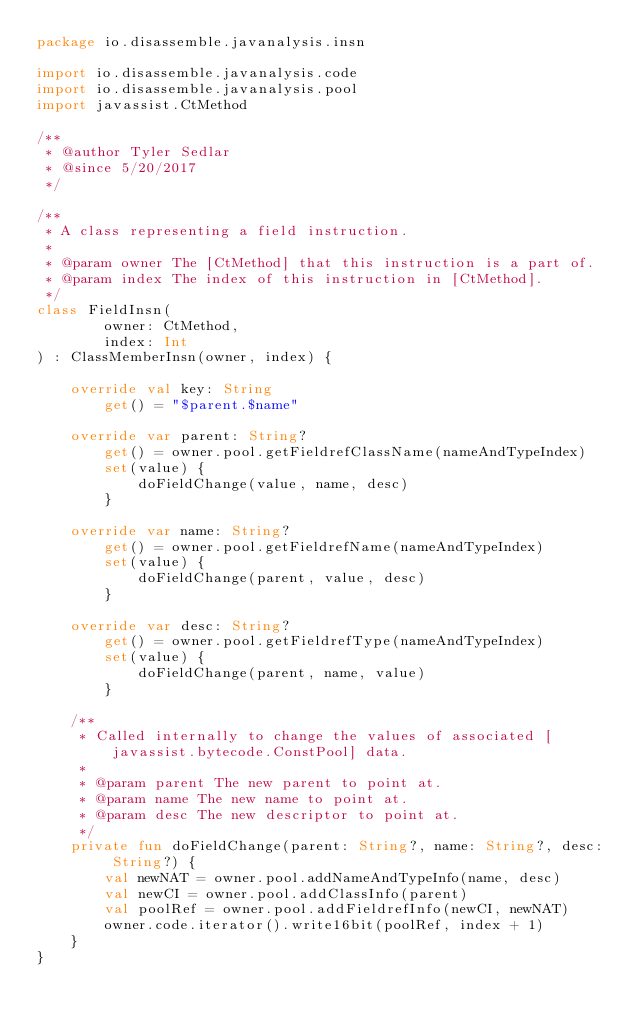Convert code to text. <code><loc_0><loc_0><loc_500><loc_500><_Kotlin_>package io.disassemble.javanalysis.insn

import io.disassemble.javanalysis.code
import io.disassemble.javanalysis.pool
import javassist.CtMethod

/**
 * @author Tyler Sedlar
 * @since 5/20/2017
 */

/**
 * A class representing a field instruction.
 *
 * @param owner The [CtMethod] that this instruction is a part of.
 * @param index The index of this instruction in [CtMethod].
 */
class FieldInsn(
        owner: CtMethod,
        index: Int
) : ClassMemberInsn(owner, index) {

    override val key: String
        get() = "$parent.$name"

    override var parent: String?
        get() = owner.pool.getFieldrefClassName(nameAndTypeIndex)
        set(value) {
            doFieldChange(value, name, desc)
        }

    override var name: String?
        get() = owner.pool.getFieldrefName(nameAndTypeIndex)
        set(value) {
            doFieldChange(parent, value, desc)
        }

    override var desc: String?
        get() = owner.pool.getFieldrefType(nameAndTypeIndex)
        set(value) {
            doFieldChange(parent, name, value)
        }

    /**
     * Called internally to change the values of associated [javassist.bytecode.ConstPool] data.
     *
     * @param parent The new parent to point at.
     * @param name The new name to point at.
     * @param desc The new descriptor to point at.
     */
    private fun doFieldChange(parent: String?, name: String?, desc: String?) {
        val newNAT = owner.pool.addNameAndTypeInfo(name, desc)
        val newCI = owner.pool.addClassInfo(parent)
        val poolRef = owner.pool.addFieldrefInfo(newCI, newNAT)
        owner.code.iterator().write16bit(poolRef, index + 1)
    }
}
</code> 